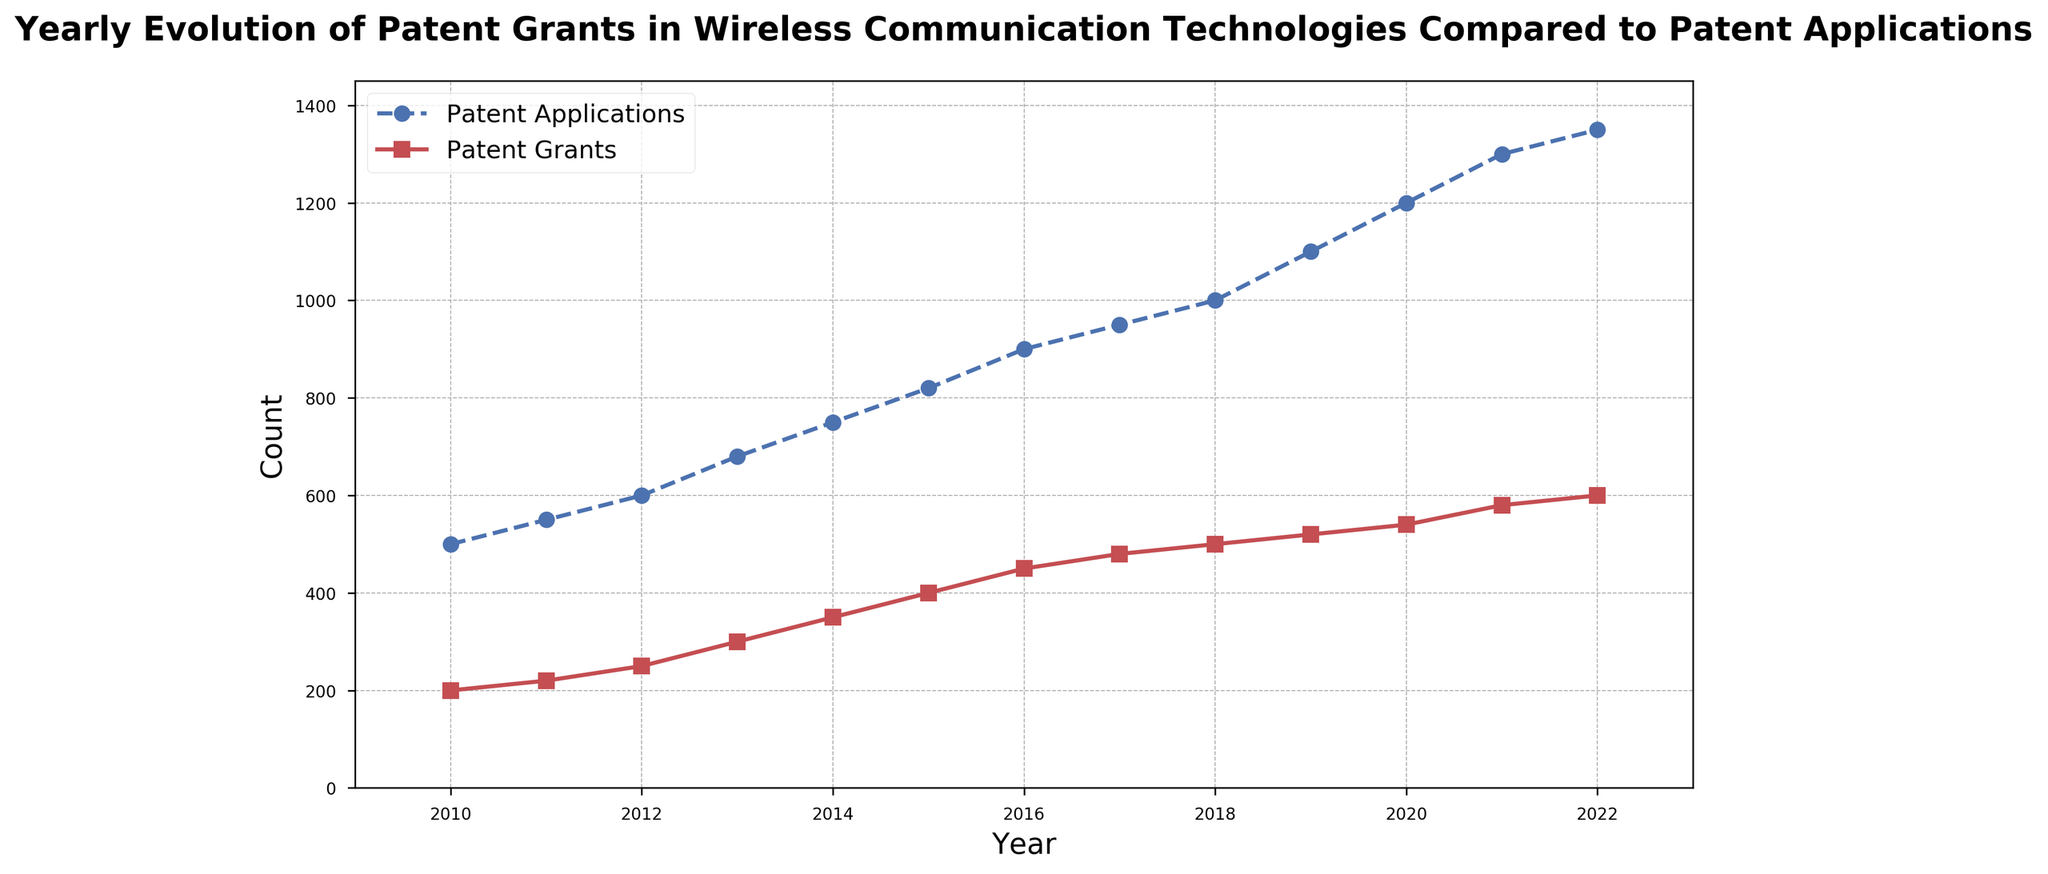What's the total number of patent applications and grants in 2022? To find the total, add the number of patent applications and patent grants for 2022. This is 1350 (applications) + 600 (grants) = 1950.
Answer: 1950 In which year did patent applications first exceed 1000? By checking the values for each year, we see that patent applications first exceed 1000 in 2018 with 1000 applications.
Answer: 2018 What is the difference in the number of patent grants between 2015 and 2016? Subtract the number of patent grants in 2015 from those in 2016: 450 (2016) - 400 (2015) = 50.
Answer: 50 Did the number of patent applications increase or decrease between 2018 and 2019? By comparing the values, the number of patent applications increased from 1000 in 2018 to 1100 in 2019.
Answer: Increased Which year had the highest number of patent grants and how many were there? By looking at the graph, the year 2022 had the highest number of patent grants, which is 600.
Answer: 2022, 600 How does the trend of patent applications compare to the trend of patent grants over the period? Both patent applications and patent grants show a general upward trend over the period, but the number of patent applications consistently exceeds the number of patent grants each year.
Answer: Upward trend for both, applications higher What was the average number of patent grants from 2010 to 2022? To find the average, first sum the patent grants for all years from 2010 to 2022, and then divide by the number of years (13). This is (200 + 220 + 250 + 300 + 350 + 400 + 450 + 480 + 500 + 520 + 540 + 580 + 600) / 13 = 5,390 / 13 = approximately 414.
Answer: 414 In which year was the difference between patent applications and grants the greatest? By calculating the difference for each year, the largest difference is found in 2022 with a difference of 1350 - 600 = 750.
Answer: 2022 How has the rate of increase in patent applications changed between the first half (2010-2015) and the second half (2016-2022) of the period? For the first half (2010-2015), calculate the increase: 820 - 500 = 320. For the second half (2016-2022), calculate the increase: 1350 - 900 = 450. Compare the two increases: 450 (second half) is greater than 320 (first half).
Answer: Second half increased more Which year saw the biggest single-year increase in patent grants and by how much? By examining the annual increases, 2014-2015 saw the largest increase: 400 (2015) - 350 (2014) = 50.
Answer: 2014-2015, 50 